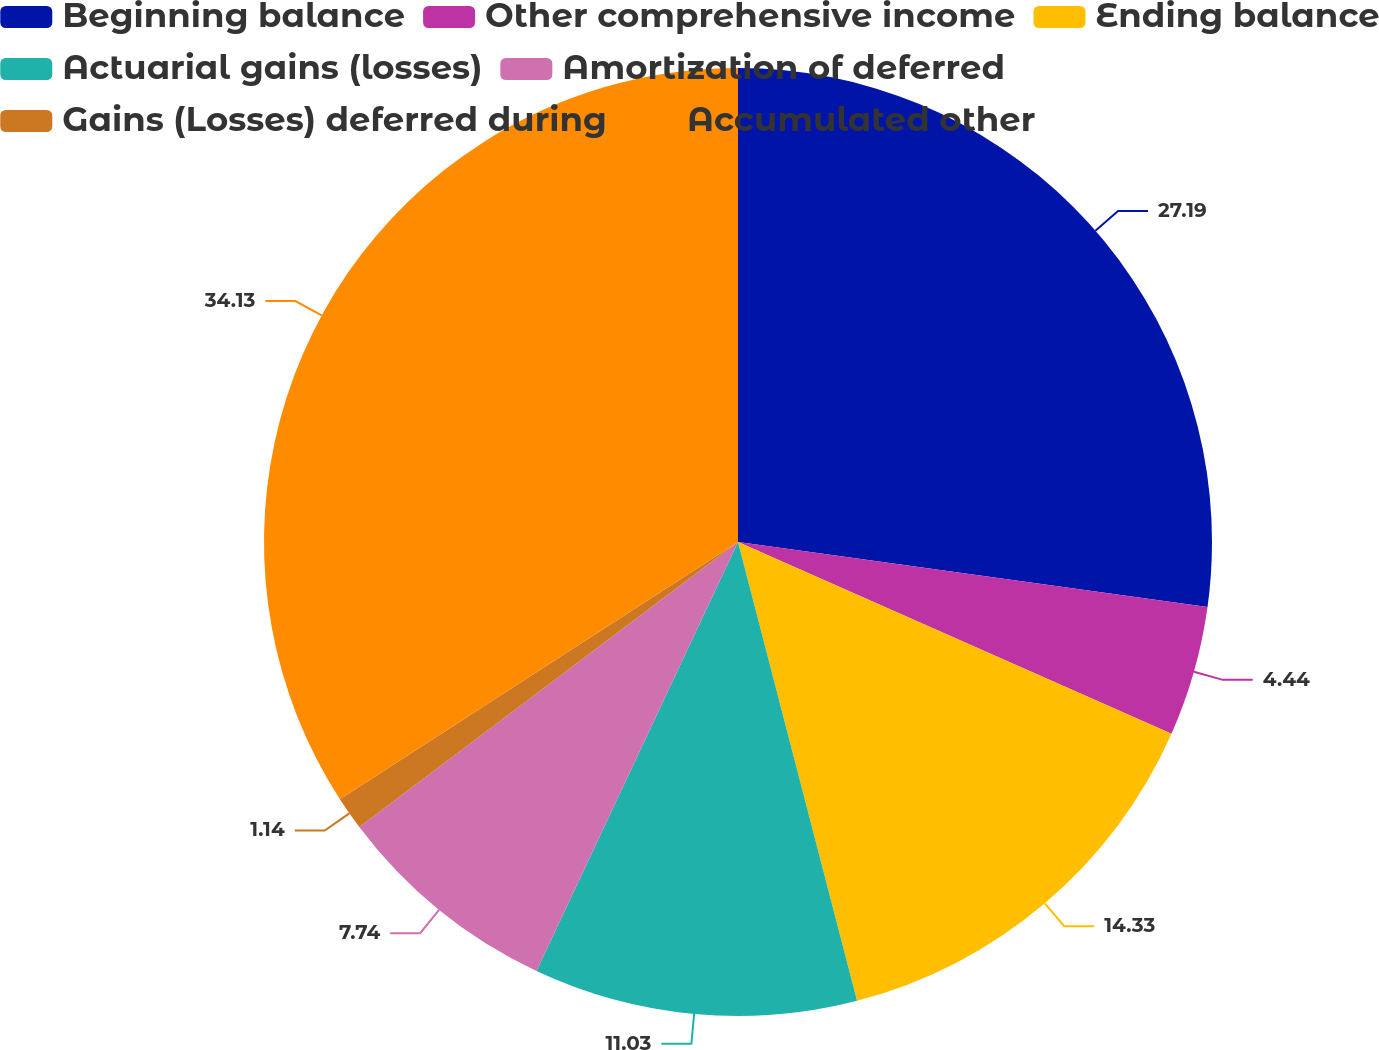Convert chart. <chart><loc_0><loc_0><loc_500><loc_500><pie_chart><fcel>Beginning balance<fcel>Other comprehensive income<fcel>Ending balance<fcel>Actuarial gains (losses)<fcel>Amortization of deferred<fcel>Gains (Losses) deferred during<fcel>Accumulated other<nl><fcel>27.19%<fcel>4.44%<fcel>14.33%<fcel>11.03%<fcel>7.74%<fcel>1.14%<fcel>34.13%<nl></chart> 